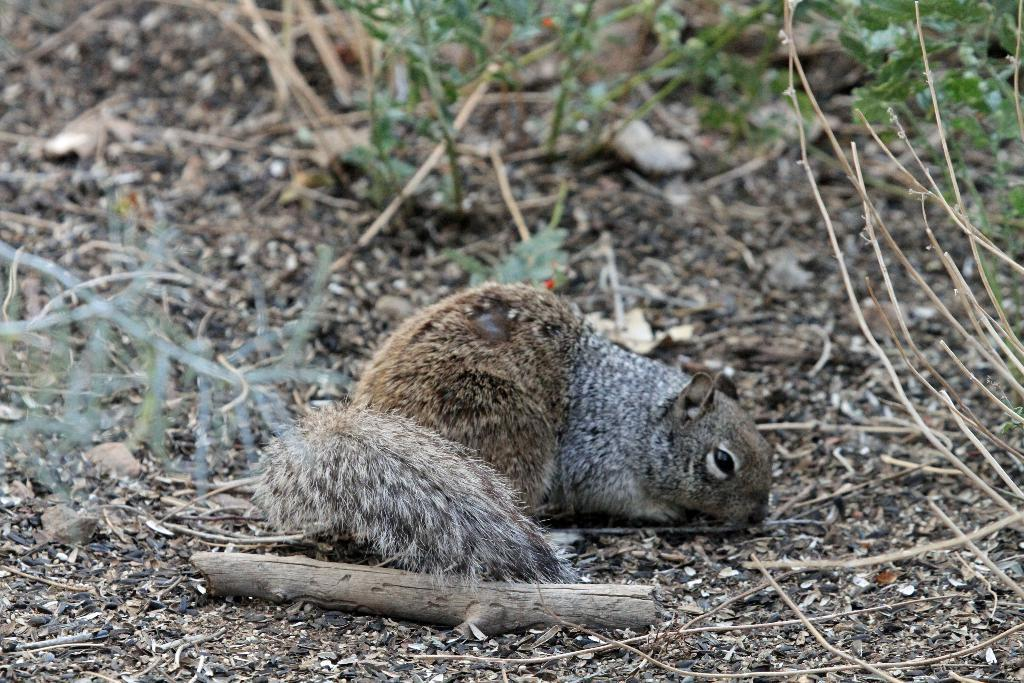What animal can be seen in the image? There is a squirrel in the image. Where is the squirrel located? The squirrel is sitting on a path. What can be seen in the background of the image? There is a wooden stick and plants in the background of the image. What type of fish can be seen swimming in the image? There is no fish present in the image; it features a squirrel sitting on a path. How many legs does the squirrel have in the image? The squirrel has four legs in the image. 